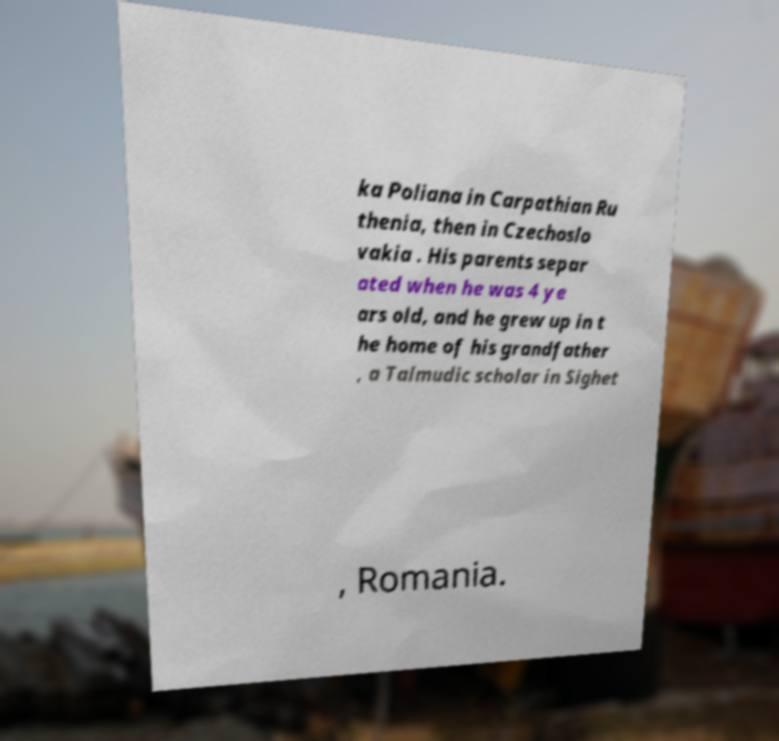Could you extract and type out the text from this image? ka Poliana in Carpathian Ru thenia, then in Czechoslo vakia . His parents separ ated when he was 4 ye ars old, and he grew up in t he home of his grandfather , a Talmudic scholar in Sighet , Romania. 